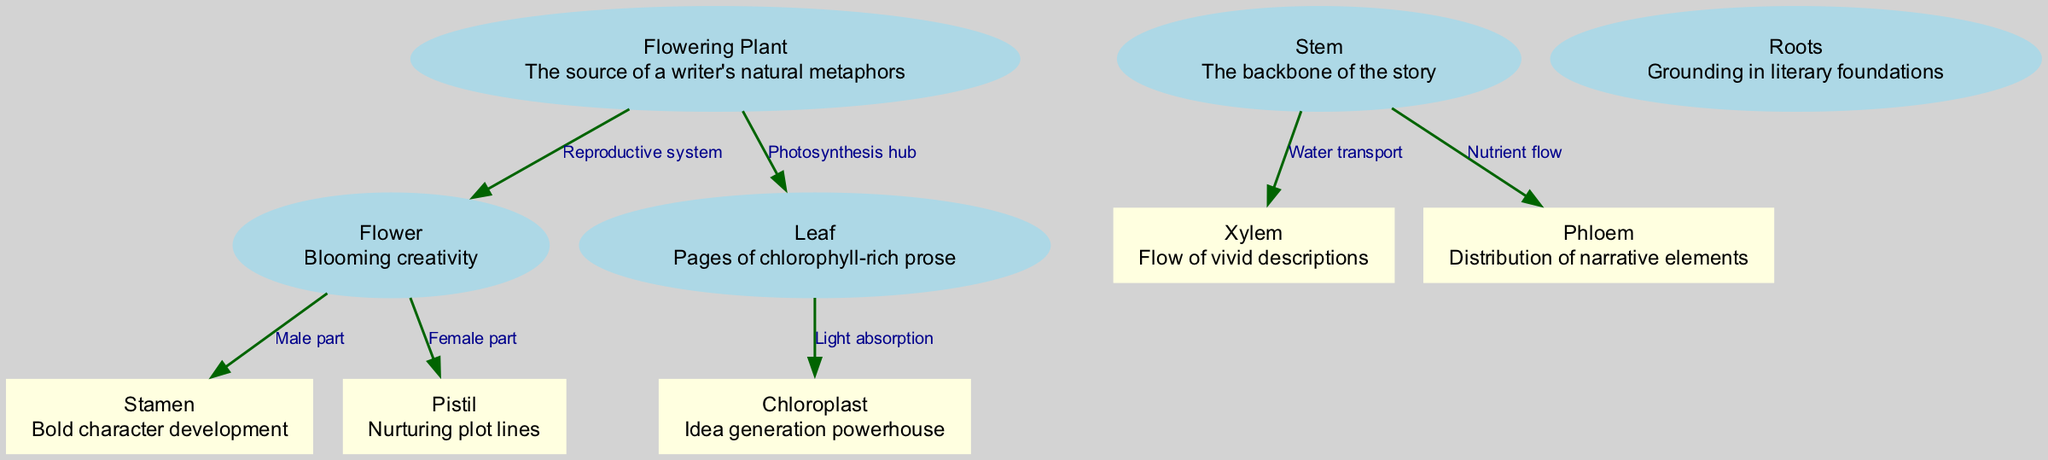What is the title of the diagram? The title is explicitly mentioned at the beginning of the data provided, which is "Flowering Plant Anatomy: From Inspiration to Page."
Answer: Flowering Plant Anatomy: From Inspiration to Page How many nodes are there in the diagram? By counting the number of unique entities represented in the nodes section of the data, there are five nodes outlined in the diagram.
Answer: 5 What does the stem provide to the plant? Looking at the edges connected to the stem, it is indicated that the stem is responsible for both nutrient flow and water transport, with specific labels on the edges highlighting this function.
Answer: Water transport, Nutrient flow Which part represents the male reproductive component? The edge from the flower to the stamen indicates that the stamen is designated as the male part of the reproductive system within the flowering plant, making it the correct answer.
Answer: Stamen What is the role of chloroplasts in the plant? The edge from the leaf to the chloroplast describes it as the "light absorption" node, suggesting that chloroplasts are crucial for the process of photosynthesis by absorbing light.
Answer: Light absorption Which node is connected to both the stamen and pistil? The flower node acts as the connection point to both the male part (stamen) and the female part (pistil), indicating that it encompasses both components of the reproductive system.
Answer: Flower What do the roots symbolize in terms of literary context? The description of the roots highlights their role as "grounding in literary foundations," suggesting a metaphorical correlation between roots and the fundamental elements of literature.
Answer: Grounding in literary foundations Which organelle is responsible for generating ideas? The description associated with the chloroplast node in the diagram indicates that it acts as an "idea generation powerhouse," equating its biological function with the creative process in writing.
Answer: Idea generation powerhouse What is the function of phloem in the plant? The edge from the stem to the phloem describes its role as the "distribution of narrative elements," signifying that it aids in the nutrient flow within the plant, paralleling how narrative elements are distributed in a story.
Answer: Distribution of narrative elements 